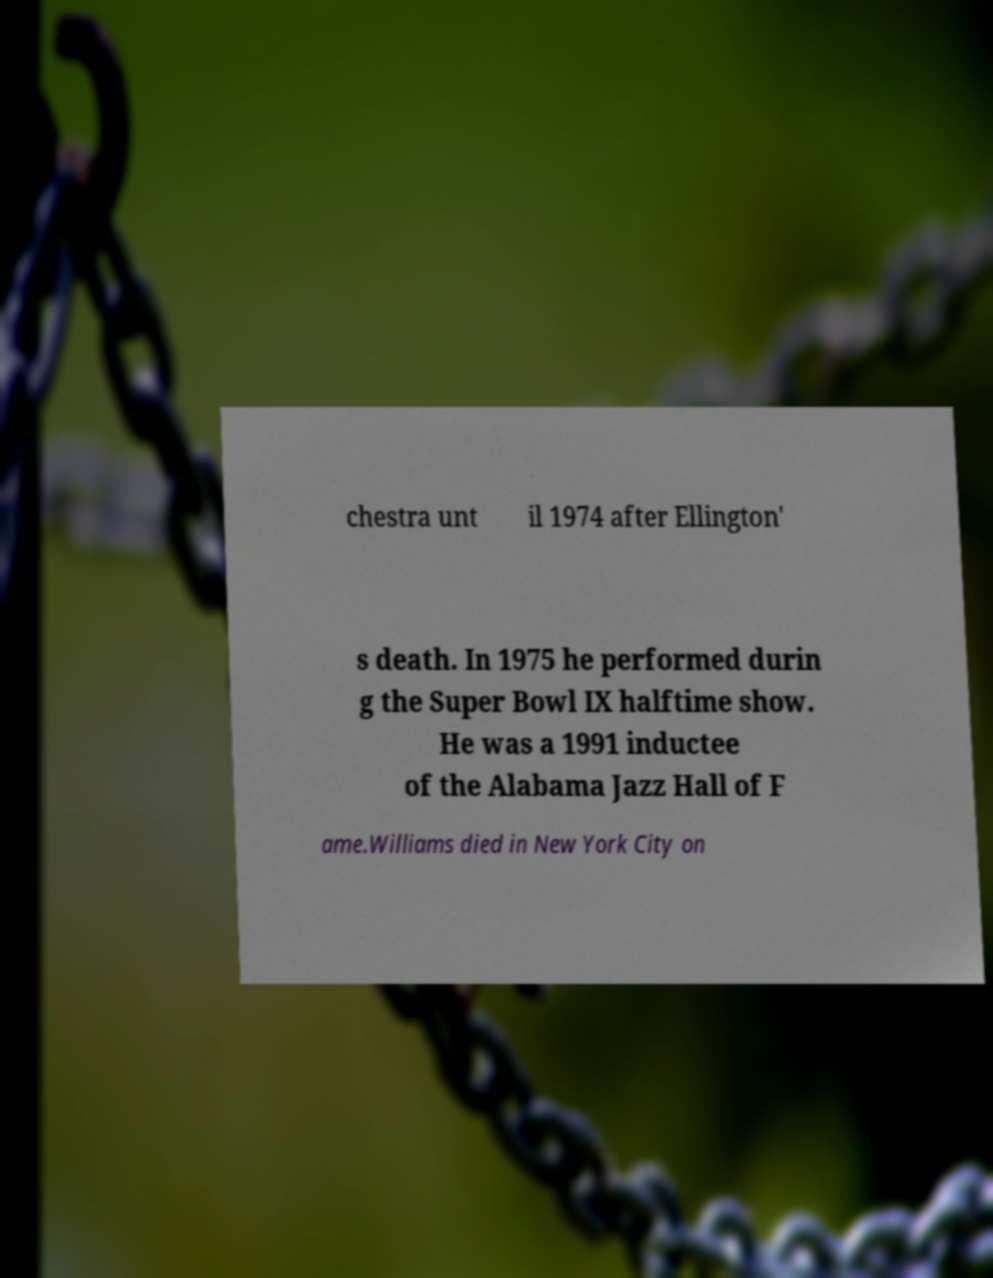I need the written content from this picture converted into text. Can you do that? chestra unt il 1974 after Ellington' s death. In 1975 he performed durin g the Super Bowl IX halftime show. He was a 1991 inductee of the Alabama Jazz Hall of F ame.Williams died in New York City on 